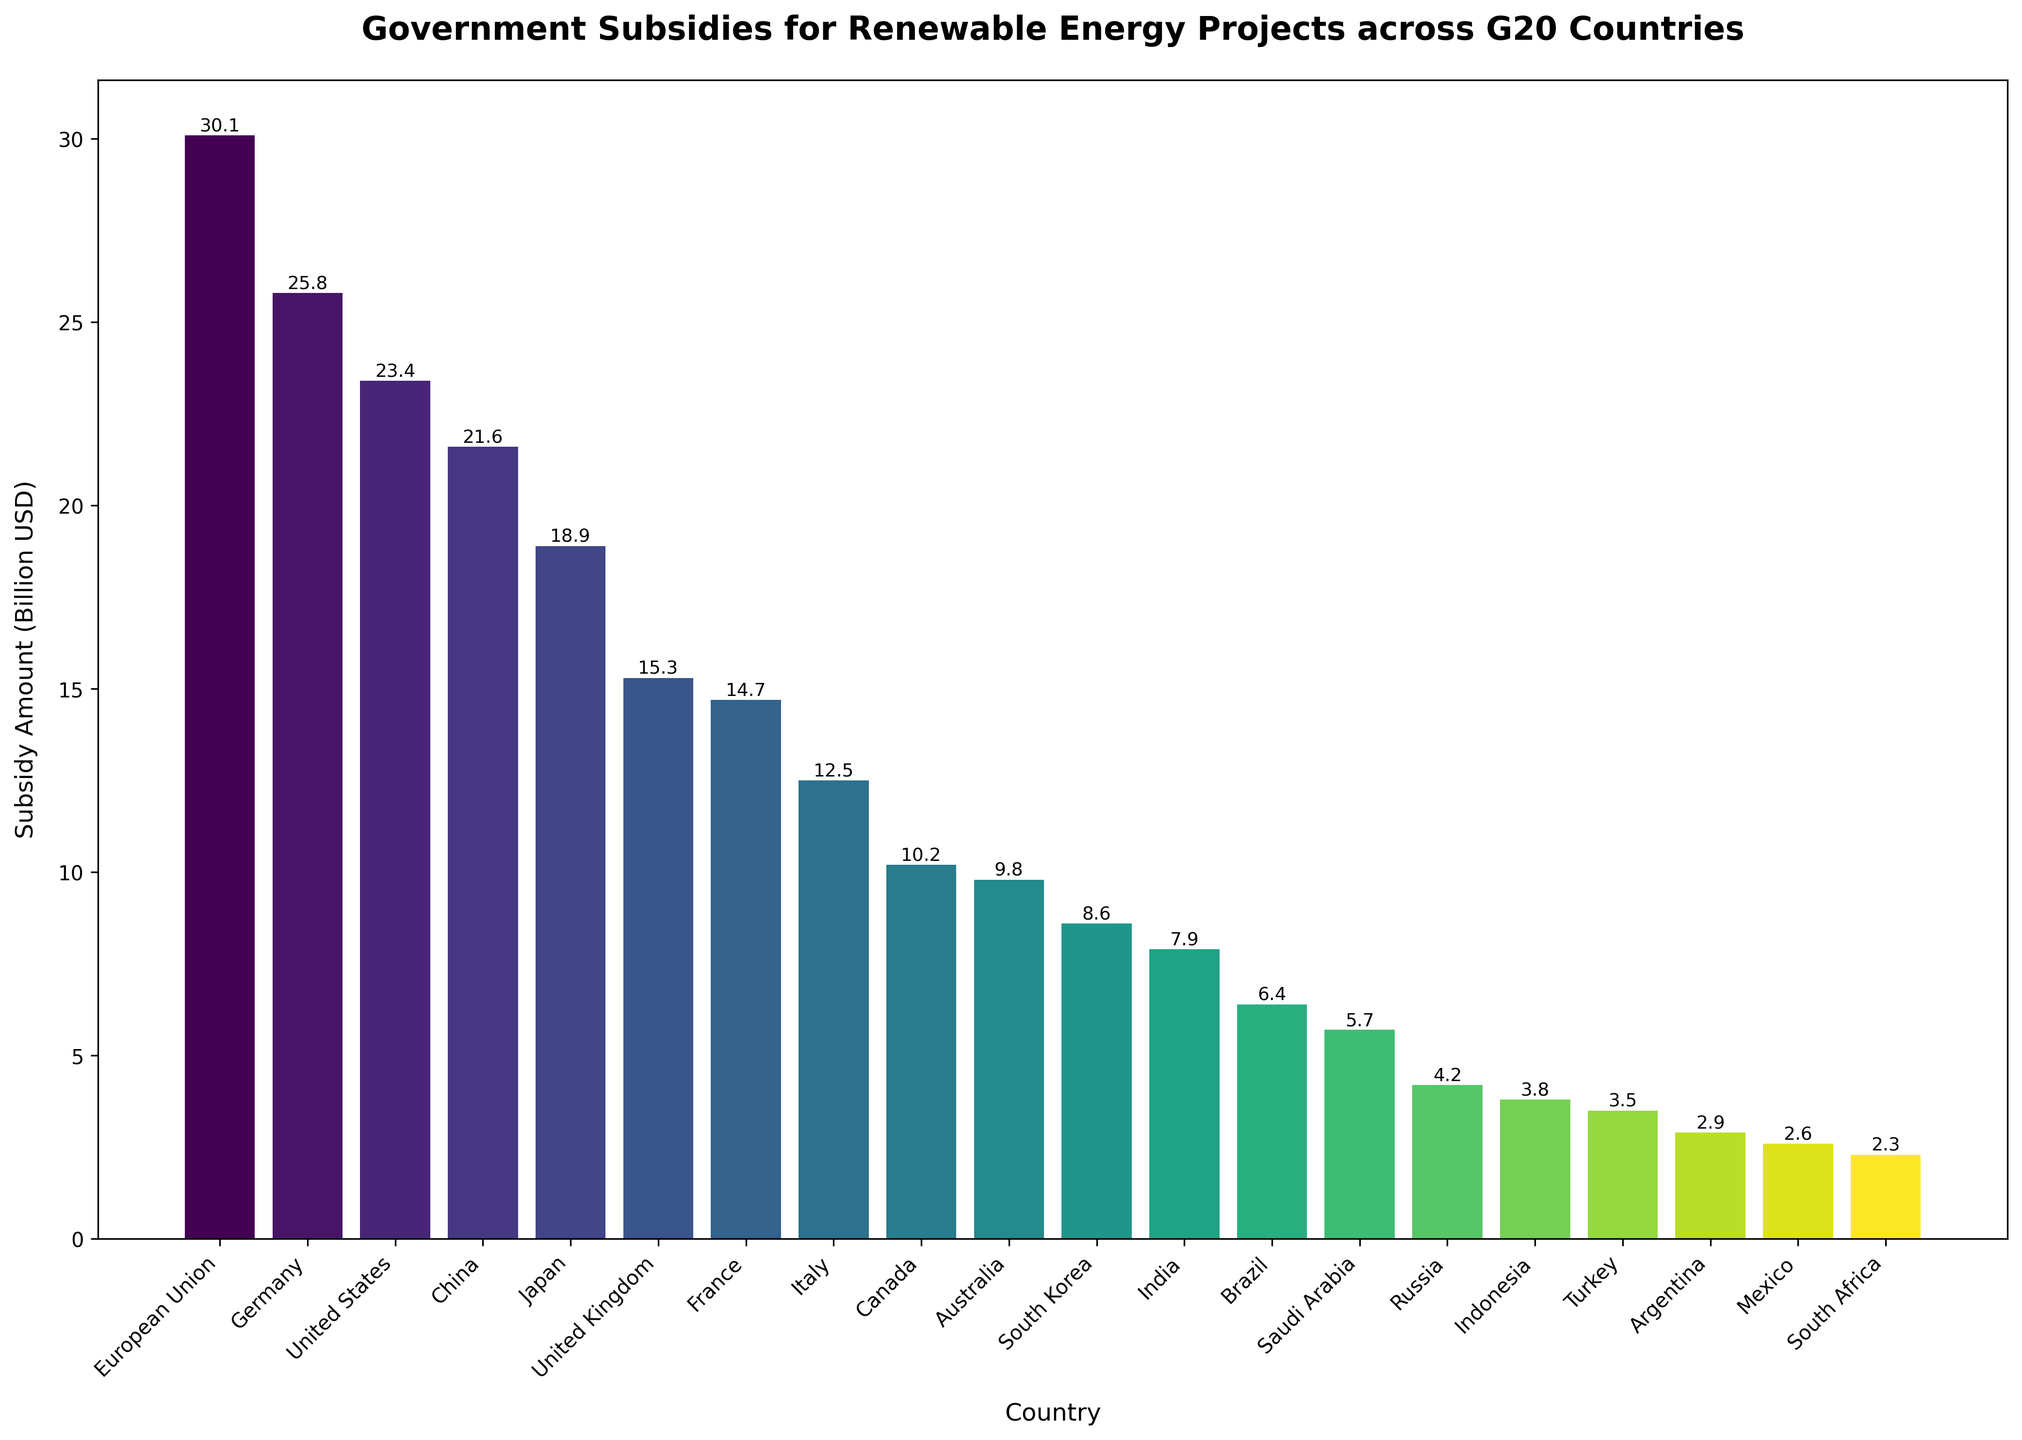Which country receives the highest subsidy for renewable energy projects? According to the bar chart, the European Union receives the highest subsidy.
Answer: European Union Which country receives the second-highest subsidy for renewable energy projects? The bar chart indicates that Germany is the country with the second-highest subsidy amount after the European Union.
Answer: Germany What is the approximate difference in subsidy amounts between the United States and China? According to the bar chart, the subsidy for the United States is 23.4 billion USD and for China is 21.6 billion USD. The difference is 23.4 - 21.6 = 1.8 billion USD.
Answer: 1.8 billion USD How many countries have subsidies greater than 20 billion USD? Looking at the bar chart, the European Union, Germany, United States, China, and Japan each have subsidies greater than 20 billion USD. Therefore, there are 5 countries.
Answer: 5 countries Which country has a subsidy amount closest to 10 billion USD? The chart shows that Canada has a subsidy amount of 10.2 billion USD, which is closest to 10 billion USD.
Answer: Canada What is the combined subsidy amount for France and Italy? The subsidies for France and Italy are 14.7 billion USD and 12.5 billion USD, respectively. Their combined subsidy amount is 14.7 + 12.5 = 27.2 billion USD.
Answer: 27.2 billion USD What is the lowest subsidy amount among the G20 countries listed, and which country receives it? According to the bar chart, South Africa has the lowest subsidy amount at 2.3 billion USD.
Answer: 2.3 billion USD, South Africa Is Saudi Arabia's subsidy amount greater or less than Brazil's? The bar chart indicates that Saudi Arabia's subsidy is 5.7 billion USD, while Brazil's subsidy is 6.4 billion USD. Thus, Saudi Arabia's subsidy amount is less.
Answer: Less Which countries have a subsidy amount between 5 and 10 billion USD? From the bar chart, the countries with subsidies between 5 and 10 billion USD are Brazil (6.4 billion USD), Saudi Arabia (5.7 billion USD), Russia (4.2 billion USD), and South Korea (8.6 billion USD).
Answer: Brazil, Saudi Arabia, South Korea What is the average subsidy amount for the top three countries with the highest subsidies? The subsidies for the European Union, Germany, and the United States are 30.1 billion USD, 25.8 billion USD, and 23.4 billion USD, respectively. The average is (30.1 + 25.8 + 23.4) / 3 = 26.43 billion USD.
Answer: 26.43 billion USD 